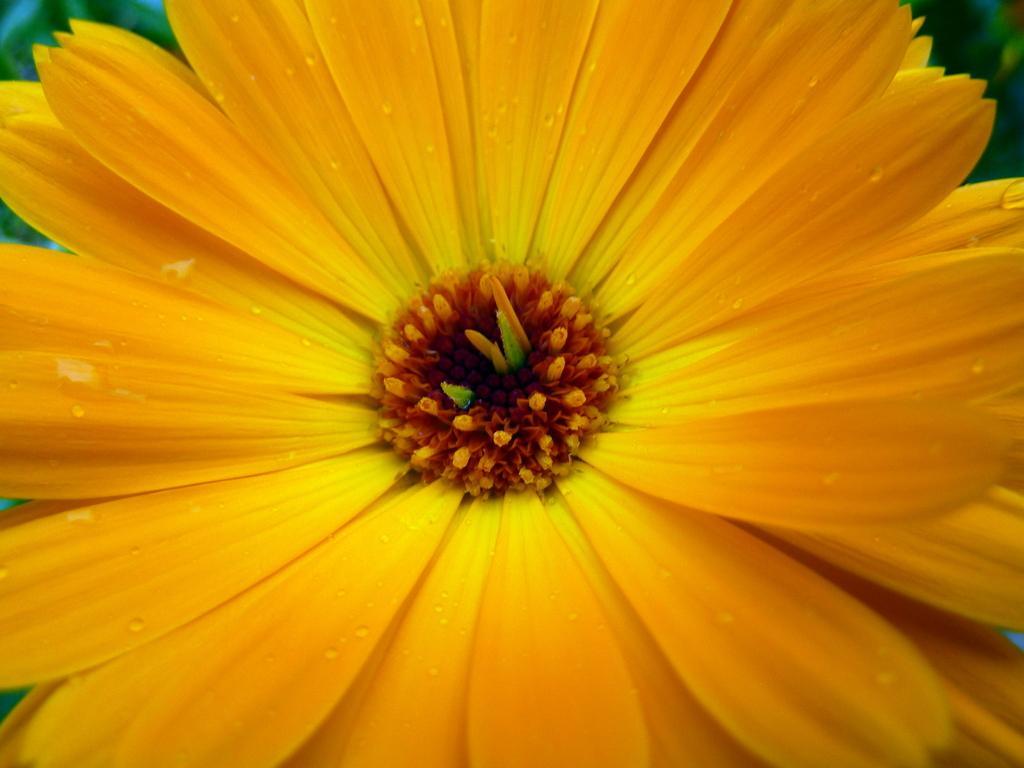Could you give a brief overview of what you see in this image? As we can see in the image there is a yellow color flower. 